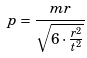<formula> <loc_0><loc_0><loc_500><loc_500>p = \frac { m r } { \sqrt { 6 \cdot \frac { r ^ { 2 } } { t ^ { 2 } } } }</formula> 